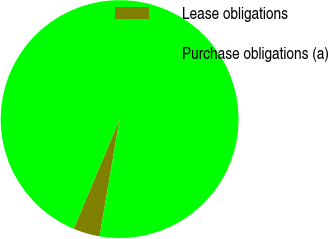Convert chart to OTSL. <chart><loc_0><loc_0><loc_500><loc_500><pie_chart><fcel>Lease obligations<fcel>Purchase obligations (a)<nl><fcel>3.62%<fcel>96.38%<nl></chart> 